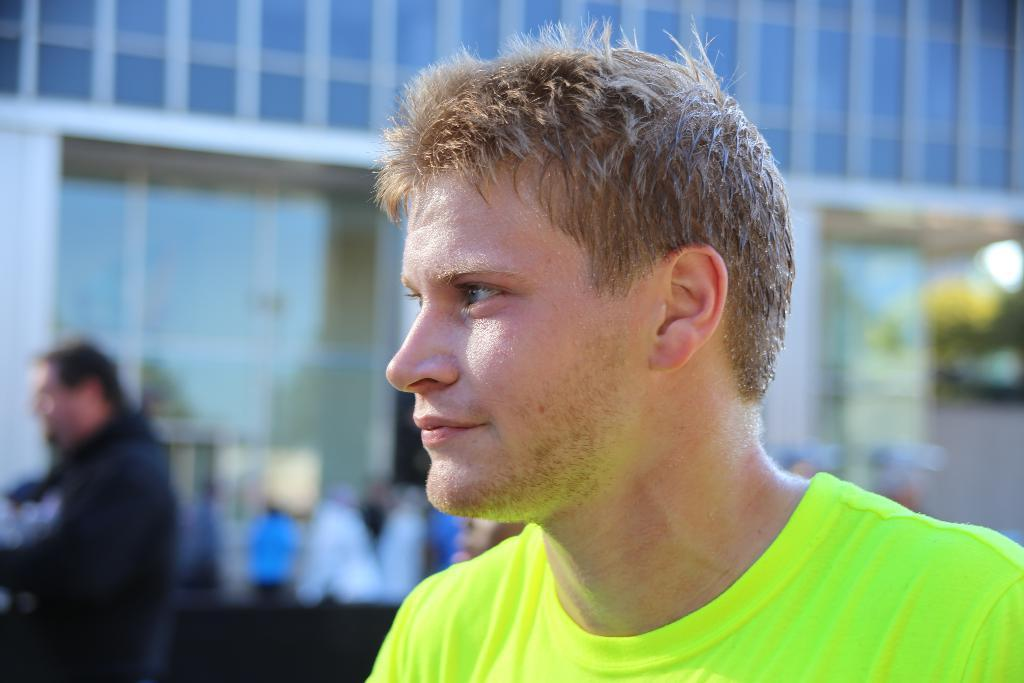How many people are in the image? There are two persons in the image. What can be seen in the background of the image? There are objects and trees in the background of the image. What type of operation is being performed by the father in the image? There is no father present in the image, and no operation is being performed. 